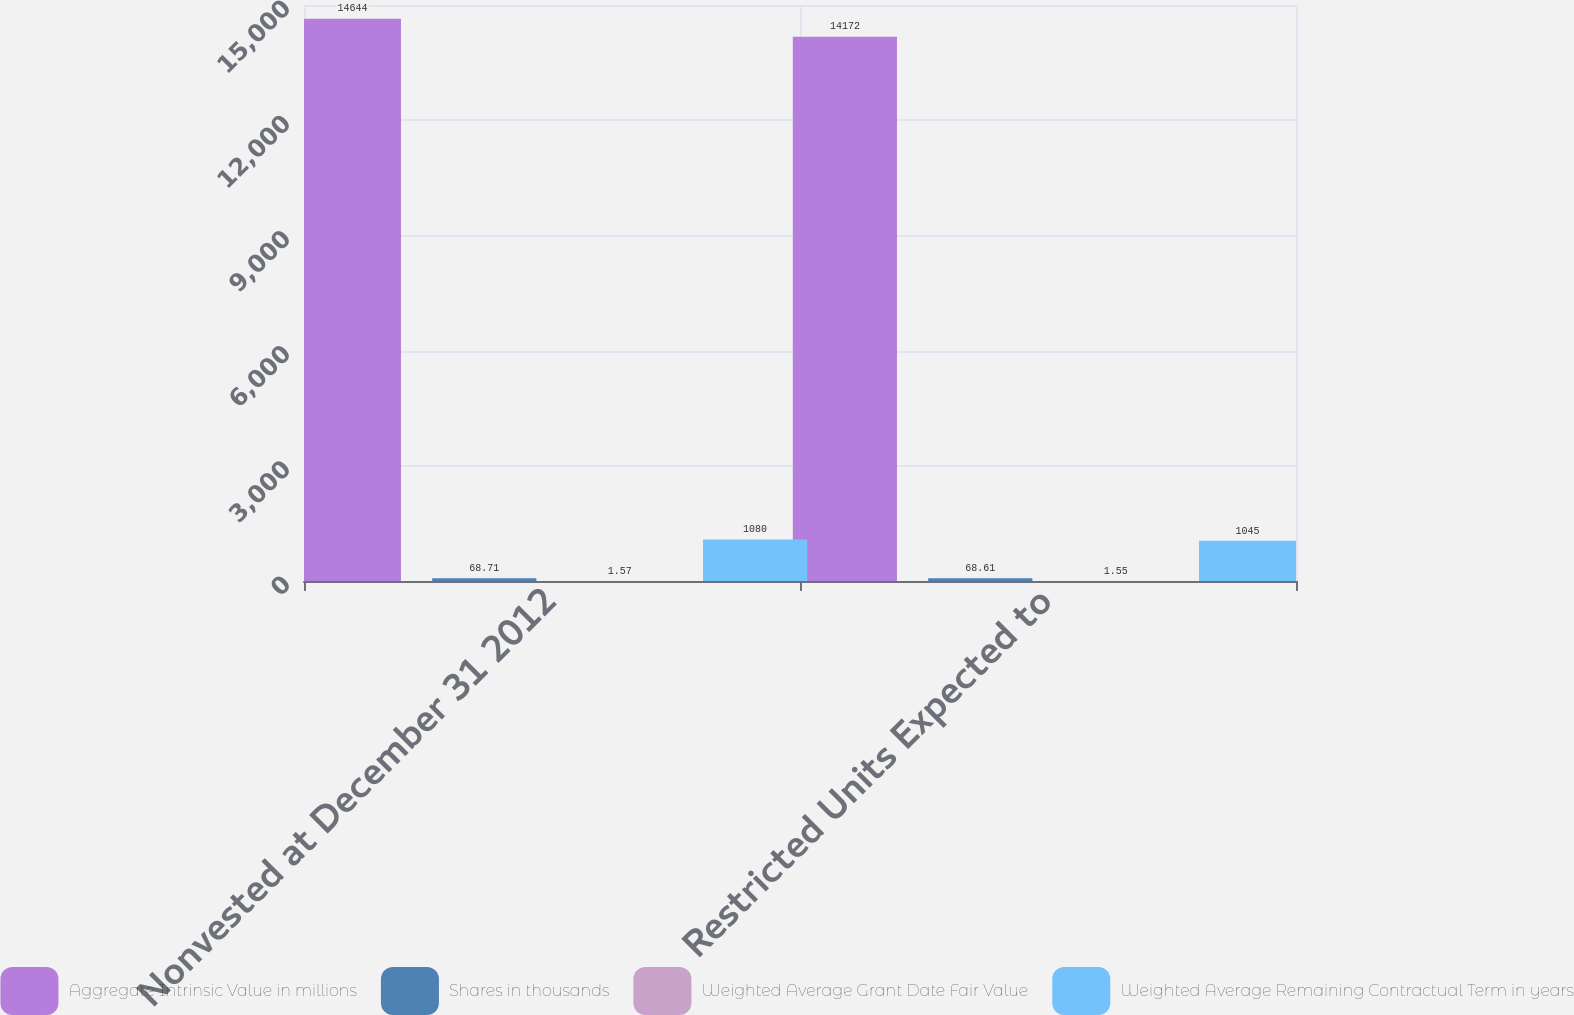<chart> <loc_0><loc_0><loc_500><loc_500><stacked_bar_chart><ecel><fcel>Nonvested at December 31 2012<fcel>Restricted Units Expected to<nl><fcel>Aggregate Intrinsic Value in millions<fcel>14644<fcel>14172<nl><fcel>Shares in thousands<fcel>68.71<fcel>68.61<nl><fcel>Weighted Average Grant Date Fair Value<fcel>1.57<fcel>1.55<nl><fcel>Weighted Average Remaining Contractual Term in years<fcel>1080<fcel>1045<nl></chart> 